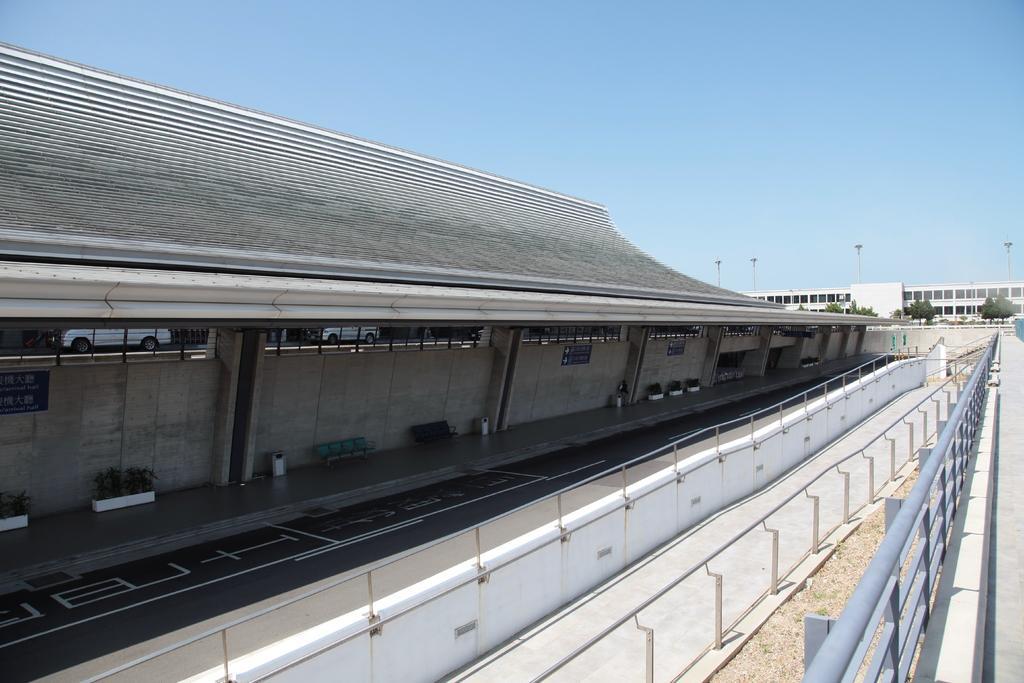Could you give a brief overview of what you see in this image? In this image we can see the buildings and there are potted plants near the wall. In front of the building we can see the railing and the ground. In the background, we can see the trees, poles and the sky. 